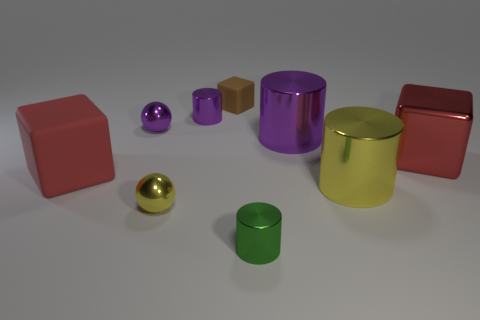Is the big yellow thing the same shape as the big matte object?
Make the answer very short. No. There is a thing that is the same color as the big metal block; what is it made of?
Give a very brief answer. Rubber. How big is the matte cube on the left side of the small purple cylinder behind the big yellow object?
Provide a short and direct response. Large. Are there any big yellow cylinders?
Give a very brief answer. Yes. There is a object left of the purple metal ball; what size is it?
Your answer should be very brief. Large. How many metallic blocks have the same color as the large matte block?
Provide a short and direct response. 1. What number of balls are either large red things or red rubber things?
Ensure brevity in your answer.  0. What is the shape of the thing that is both right of the large purple metallic cylinder and behind the red rubber block?
Your answer should be compact. Cube. Are there any yellow shiny cylinders that have the same size as the purple ball?
Offer a terse response. No. What number of things are either tiny green shiny things that are in front of the large purple metal object or small things?
Provide a succinct answer. 5. 